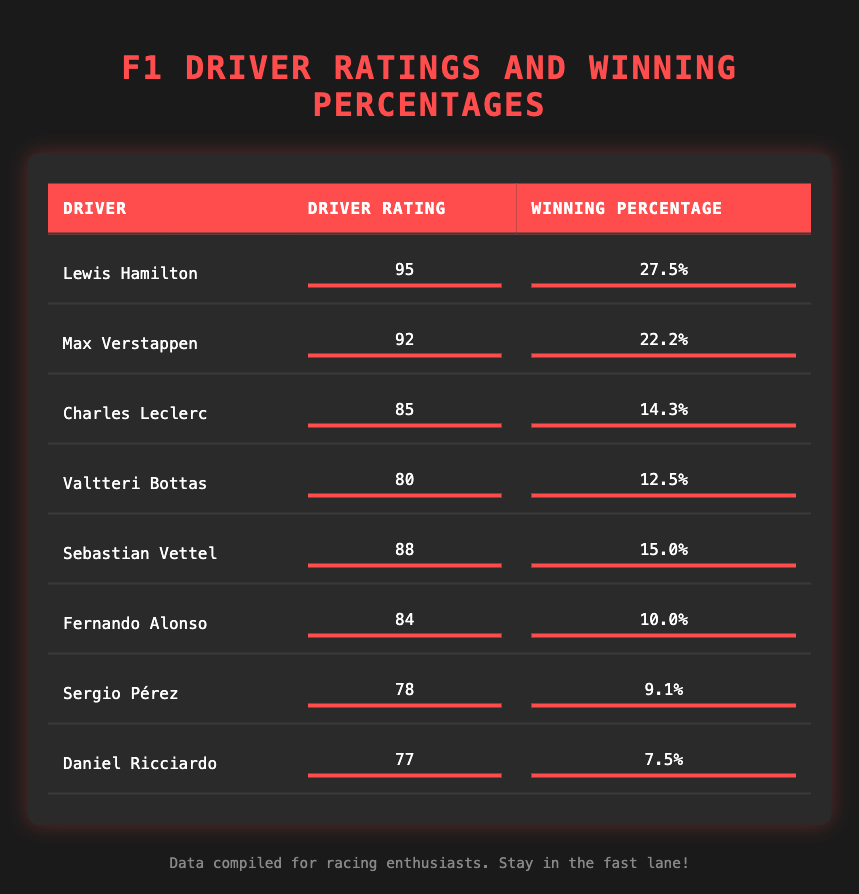What is the driver rating of Lewis Hamilton? Lewis Hamilton's driver rating is directly listed in the table under the "Driver Rating" column. It shows as 95.
Answer: 95 Which driver has the lowest winning percentage? In the table, the "Winning Percentage" column allows us to examine the values. The lowest percentage listed is 7.5% for Daniel Ricciardo.
Answer: 7.5% What is the difference in winning percentages between Lewis Hamilton and Max Verstappen? To find the difference, we subtract Max Verstappen's winning percentage (22.2%) from Lewis Hamilton's (27.5%). The difference is 27.5% - 22.2% = 5.3%.
Answer: 5.3% True or False: Charles Leclerc has a driver rating greater than 85. According to the table, Charles Leclerc's driver rating is 85. Since it is equal, the answer to this statement is False.
Answer: False What is the average driver rating of all the drivers listed? To calculate the average, we sum the driver ratings: 95 + 92 + 85 + 80 + 88 + 84 + 78 + 77 = 699. There are 8 drivers, so we divide 699 by 8, resulting in 87.375.
Answer: 87.375 Which driver has a winning percentage closest to 10%? We can compare the "Winning Percentage" values for all drivers. Fernando Alonso has a winning percentage of 10.0%, which matches exactly, making him the closest.
Answer: Fernando Alonso What is the total winning percentage of the top three drivers by rating? The top three drivers are Lewis Hamilton (27.5%), Max Verstappen (22.2%), and Charles Leclerc (14.3%). Adding their winning percentages gives 27.5 + 22.2 + 14.3 = 64.0%.
Answer: 64.0% True or False: Sergio Pérez has a higher rating than Valtteri Bottas. The table shows that Sergio Pérez has a rating of 78, while Valtteri Bottas has a rating of 80. Thus, the statement is False.
Answer: False What is the driver rating of the driver with the second-lowest winning percentage? The second-lowest winning percentage is 9.1% for Sergio Pérez. Referring to the table, Sergio Pérez's driver rating is 78.
Answer: 78 